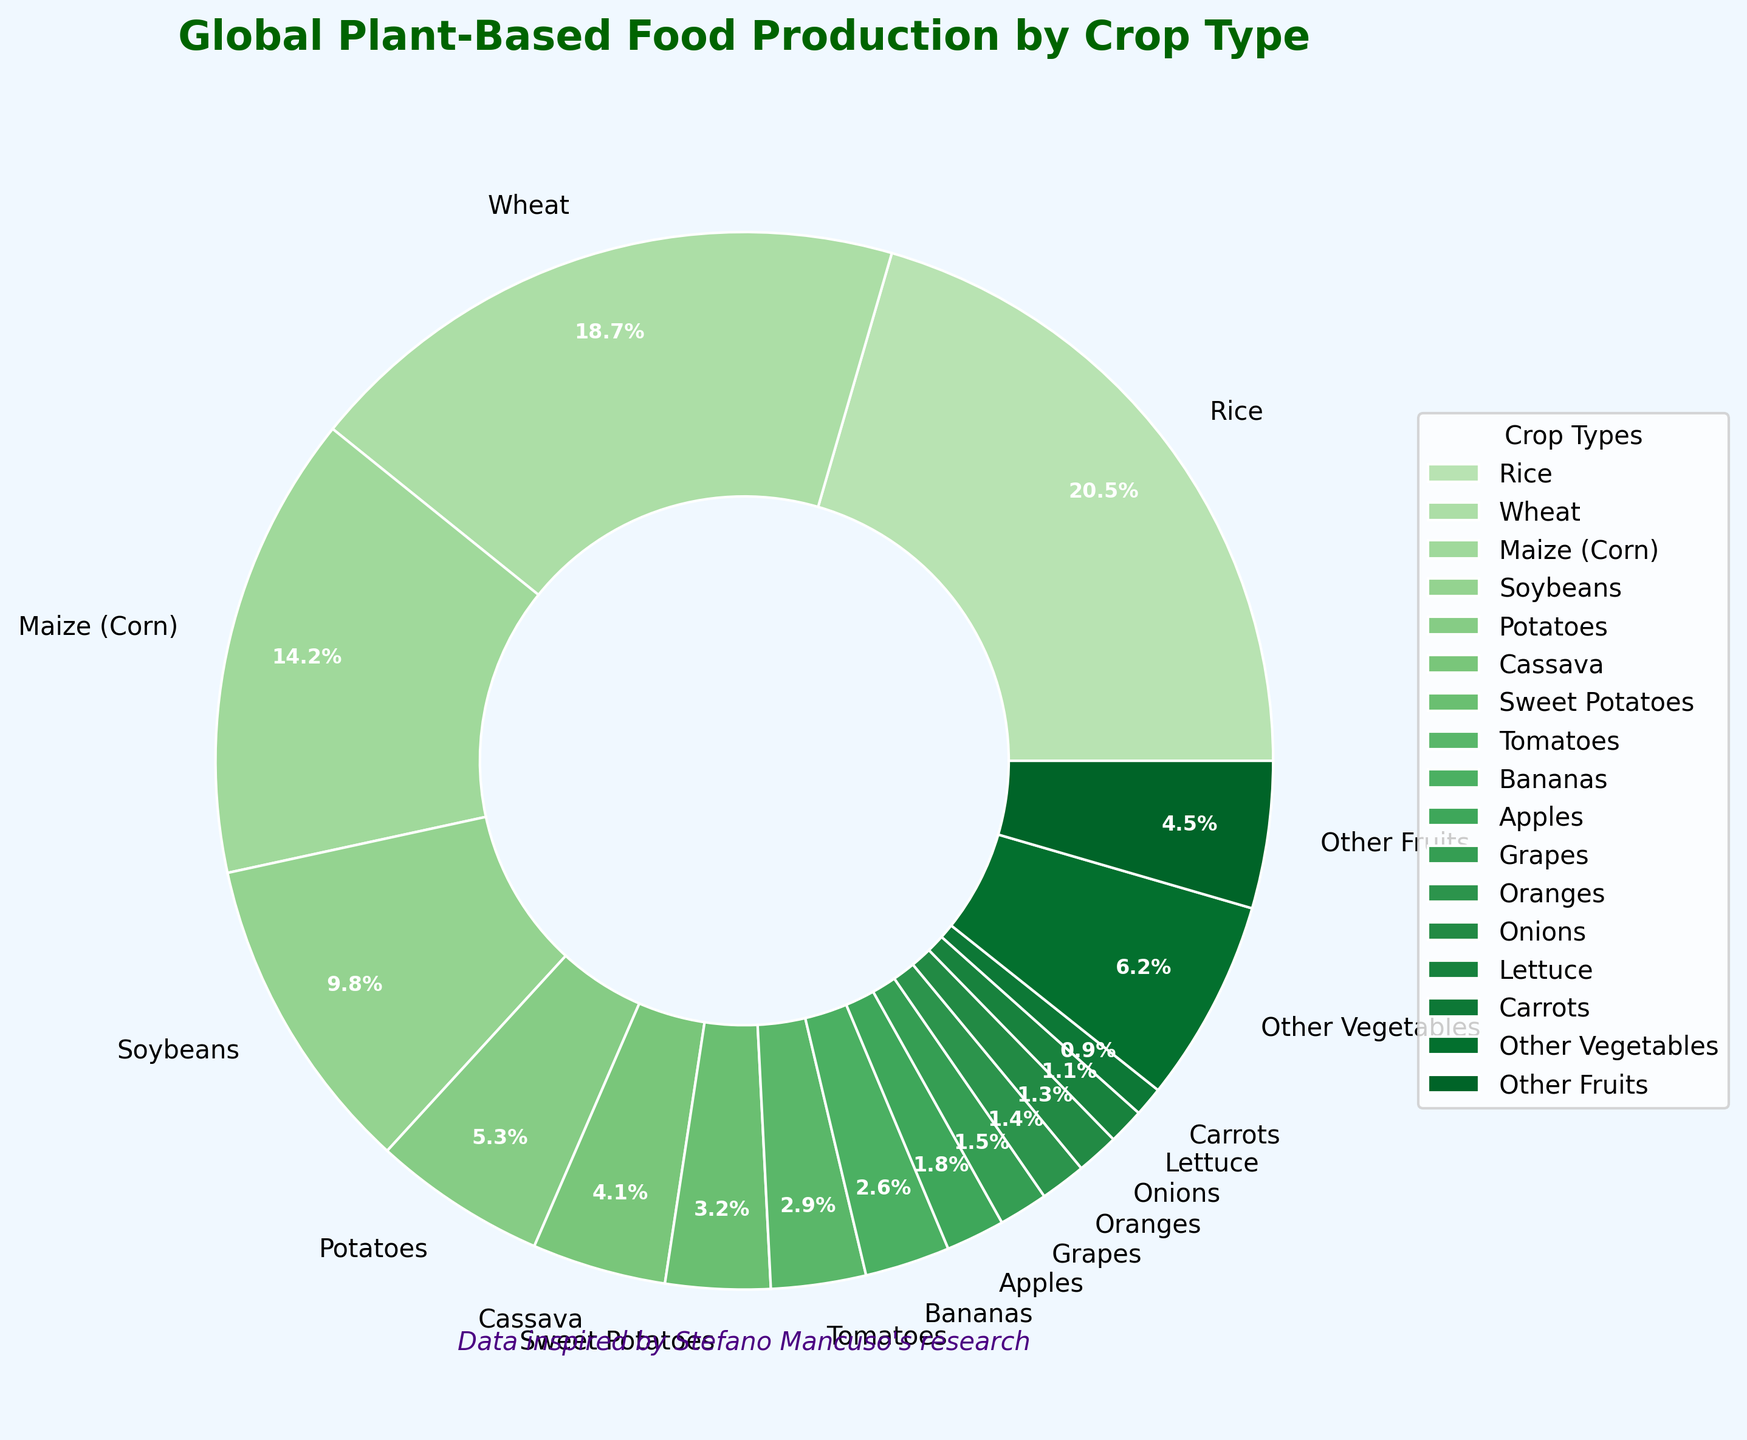What crop has the highest percentage of global plant-based food production? The figure shows different crops and their respective contributions. Rice has the largest segment with 20.5%.
Answer: Rice What are the combined contributions of Maize and Wheat to global plant-based food production? Maize (Corn) contributes 14.2% and Wheat contributes 18.7%. Adding these percentages together (14.2 + 18.7) gives a combined total of 32.9%.
Answer: 32.9% Which crop contributes less, Apples or Onions? By comparing the segments for Apples and Onions, Apples contribute 1.8% while Onions contribute 1.3%, making Onions the crop with the lesser contribution.
Answer: Onions How much more does Rice contribute compared to Bananas? Rice contributes 20.5% while Bananas contribute 2.6%. The difference is calculated as 20.5 - 2.6 = 17.9%.
Answer: 17.9% What is the average percentage of production for Sweet Potatoes, Tomatoes, and Bananas? Sweet Potatoes contribute 3.2%, Tomatoes contribute 2.9%, and Bananas contribute 2.6%. The average is calculated as (3.2 + 2.9 + 2.6) / 3 = 2.9%.
Answer: 2.9% Which segment is the smallest among the mentioned crops, and what is its percentage? The smallest segment among all listed crops is Carrots, which contributes 0.9%.
Answer: Carrots What is the total percentage contribution of all crops categorized under "Other Vegetables" and "Other Fruits"? "Other Vegetables" contribute 6.2%, and "Other Fruits" contribute 4.5%. Adding them together gives 6.2 + 4.5 = 10.7%.
Answer: 10.7% How does the percentage contribution of Potatoes compare to that of Cassava? Potatoes contribute 5.3%, while Cassava contributes 4.1%. We can see that the contribution of Potatoes is greater than that of Cassava.
Answer: Potatoes If you combine the contributions of the top three crops, what is their total percentage? The top three crops are Rice (20.5%), Wheat (18.7%), and Maize (14.2%). Adding these together gives 20.5 + 18.7 + 14.2 = 53.4%.
Answer: 53.4% How many crops have a contribution greater than 2% but less than 10%? From the figure, the crops meeting this criterion are Soybeans (9.8%), Potatoes (5.3%), Cassava (4.1%), Sweet Potatoes (3.2%), and Tomatoes (2.9%). This makes a total of 5 crops.
Answer: 5 